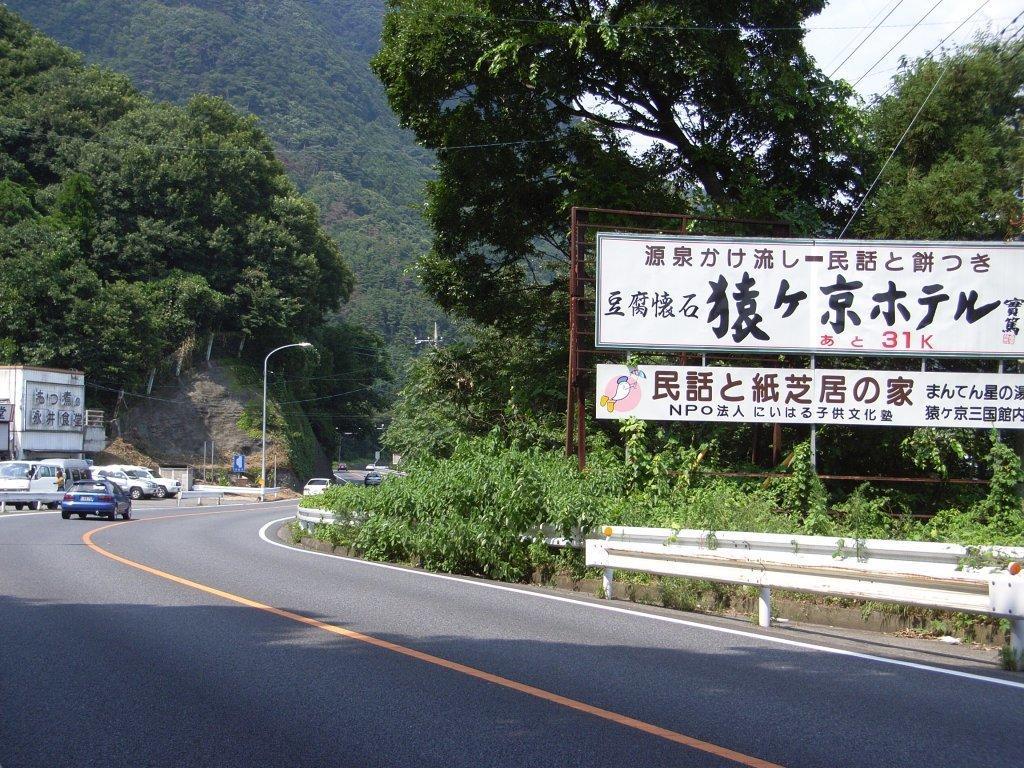Can you describe this image briefly? In this image I can see number of vehicles on roads. I can also see orange and white colour lines on this road. In the background I can see number of trees, wires, a street light, few poles, few white colour boards and on these boards I can see something is written. 